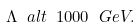Convert formula to latex. <formula><loc_0><loc_0><loc_500><loc_500>\Lambda \ a l t \ 1 0 0 0 \ G e V .</formula> 